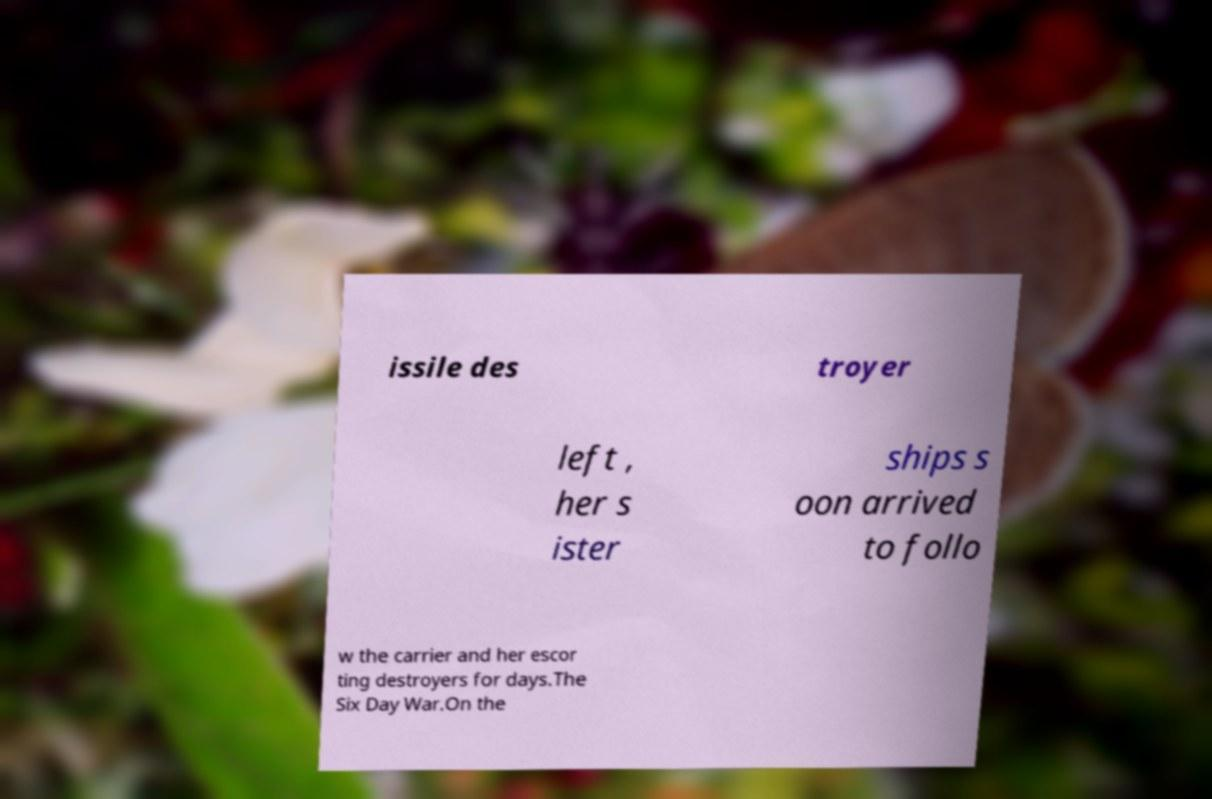Can you read and provide the text displayed in the image?This photo seems to have some interesting text. Can you extract and type it out for me? issile des troyer left , her s ister ships s oon arrived to follo w the carrier and her escor ting destroyers for days.The Six Day War.On the 